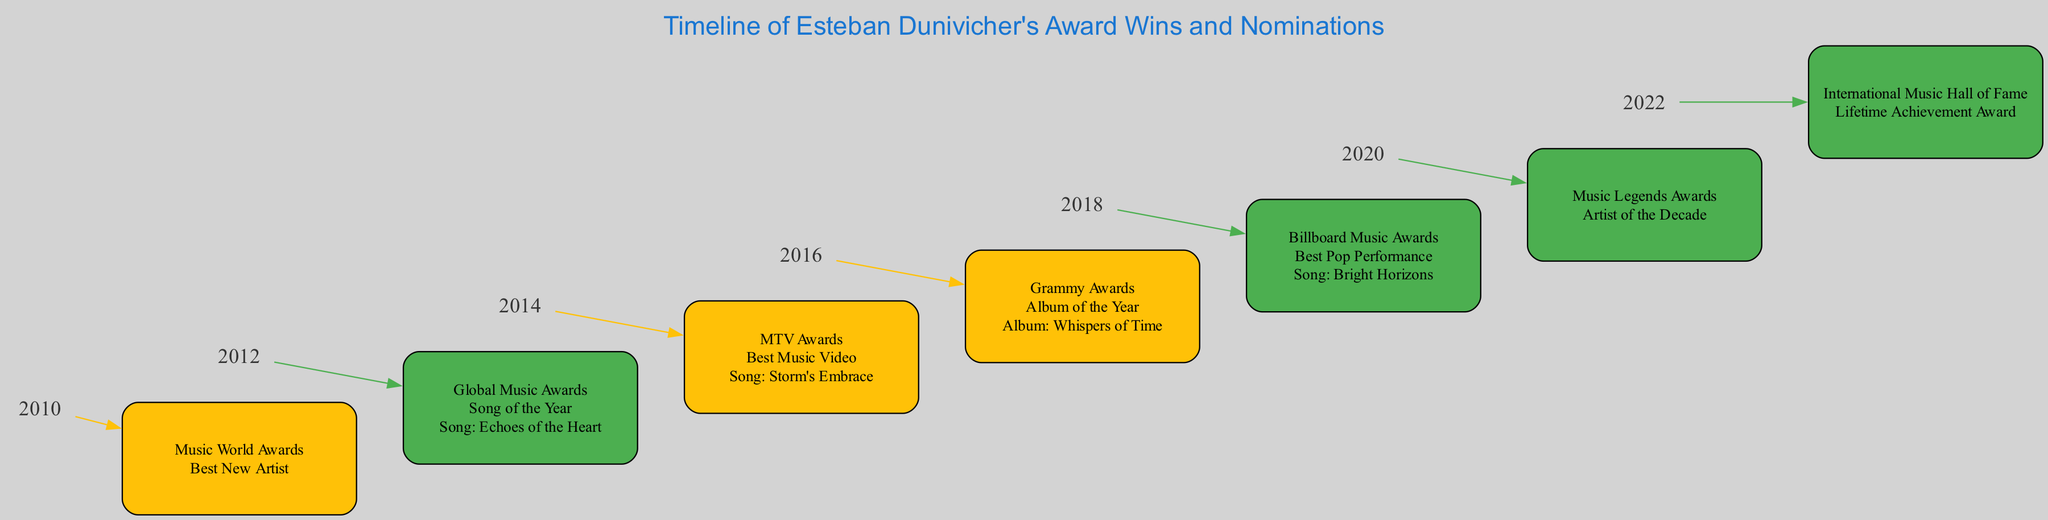What is the first event listed on the timeline? The timeline starts with the event "Music World Awards" in 2010 where Esteban Dunivicher was nominated for "Best New Artist." Hence, the first event is the Music World Awards.
Answer: Music World Awards In which year did Esteban Dunivicher win the "Song of the Year"? According to the diagram, Esteban Dunivicher won the "Song of the Year" at the Global Music Awards in 2012. The year is identified directly from that event's position on the timeline.
Answer: 2012 How many wins does Esteban Dunivicher have according to the diagram? The diagram outlines three wins: in 2012 for "Song of the Year," 2018 for "Best Pop Performance," and 2022 for the "Lifetime Achievement Award." Counting these events gives a total of three wins.
Answer: 3 What category did Esteban Dunivicher receive a nomination for in 2014? In 2014, the diagram shows that Esteban Dunivicher was nominated for "Best Music Video". This is found by locating the corresponding event node for that year and reading the category.
Answer: Best Music Video Which event corresponds to the year 2020? For the year 2020, the timeline indicates the event "Music Legends Awards," where Esteban Dunivicher won the "Artist of the Decade." The answer can be derived by locating the year node and reviewing the connected event node.
Answer: Music Legends Awards What is the result of the nomination in 2016? In 2016, the result shown for the Grammy Awards under the "Album of the Year" nomination is "Nomination." This is determined by identifying the appropriate year and reviewing the result descriptor.
Answer: Nomination Which song was associated with Esteban Dunivicher's win in 2018? The song associated with the win in 2018 for "Best Pop Performance" at the Billboard Music Awards is "Bright Horizons." This is revealed by checking the event node for that year, which includes the specified song.
Answer: Bright Horizons How many events are included in the timeline? The timeline presents a total of seven events from 2010 to 2022. By simply counting the elements listed in the diagram, we find the total number of events documented.
Answer: 7 What color indicates a win in the diagram? In the diagram, a win is represented with the color green (#4CAF50). This can be identified by observing the fill color used for the nodes corresponding to winning events.
Answer: Green 